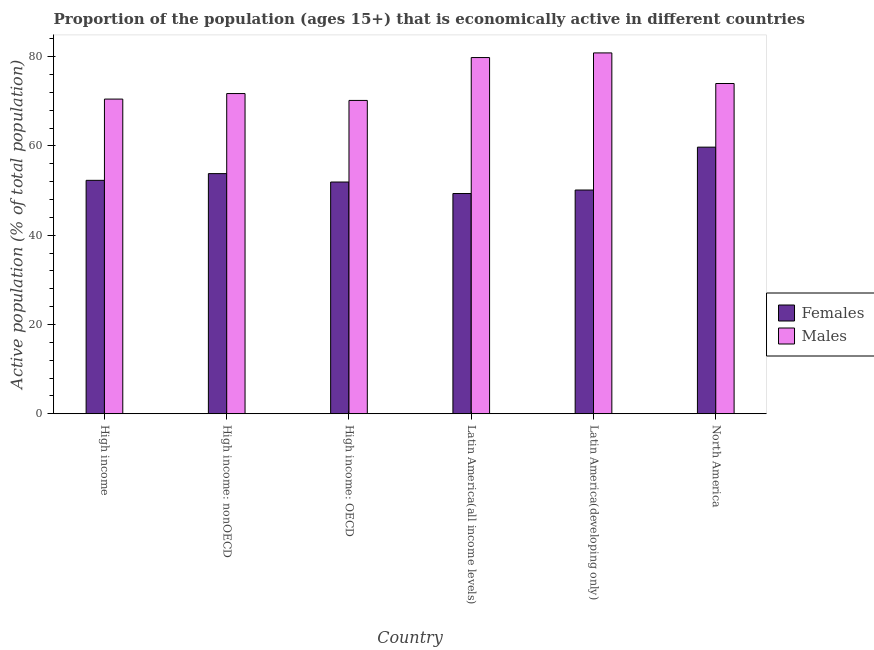How many different coloured bars are there?
Give a very brief answer. 2. How many groups of bars are there?
Give a very brief answer. 6. Are the number of bars on each tick of the X-axis equal?
Your answer should be compact. Yes. How many bars are there on the 3rd tick from the left?
Your answer should be compact. 2. What is the label of the 5th group of bars from the left?
Your answer should be compact. Latin America(developing only). What is the percentage of economically active male population in Latin America(developing only)?
Provide a short and direct response. 80.84. Across all countries, what is the maximum percentage of economically active male population?
Give a very brief answer. 80.84. Across all countries, what is the minimum percentage of economically active male population?
Ensure brevity in your answer.  70.19. In which country was the percentage of economically active male population maximum?
Provide a succinct answer. Latin America(developing only). In which country was the percentage of economically active female population minimum?
Your answer should be very brief. Latin America(all income levels). What is the total percentage of economically active male population in the graph?
Offer a terse response. 447.06. What is the difference between the percentage of economically active male population in High income: nonOECD and that in Latin America(all income levels)?
Your answer should be very brief. -8.06. What is the difference between the percentage of economically active female population in Latin America(developing only) and the percentage of economically active male population in High income?
Provide a succinct answer. -20.37. What is the average percentage of economically active male population per country?
Ensure brevity in your answer.  74.51. What is the difference between the percentage of economically active female population and percentage of economically active male population in Latin America(all income levels)?
Make the answer very short. -30.46. What is the ratio of the percentage of economically active female population in High income: OECD to that in Latin America(all income levels)?
Make the answer very short. 1.05. What is the difference between the highest and the second highest percentage of economically active male population?
Your response must be concise. 1.04. What is the difference between the highest and the lowest percentage of economically active male population?
Provide a short and direct response. 10.65. In how many countries, is the percentage of economically active male population greater than the average percentage of economically active male population taken over all countries?
Offer a terse response. 2. Is the sum of the percentage of economically active female population in High income and High income: nonOECD greater than the maximum percentage of economically active male population across all countries?
Provide a short and direct response. Yes. What does the 2nd bar from the left in High income: OECD represents?
Provide a short and direct response. Males. What does the 2nd bar from the right in Latin America(developing only) represents?
Offer a very short reply. Females. How many bars are there?
Give a very brief answer. 12. Are all the bars in the graph horizontal?
Provide a short and direct response. No. How many countries are there in the graph?
Make the answer very short. 6. Does the graph contain grids?
Offer a terse response. No. What is the title of the graph?
Provide a short and direct response. Proportion of the population (ages 15+) that is economically active in different countries. Does "Overweight" appear as one of the legend labels in the graph?
Offer a terse response. No. What is the label or title of the X-axis?
Offer a very short reply. Country. What is the label or title of the Y-axis?
Provide a succinct answer. Active population (% of total population). What is the Active population (% of total population) in Females in High income?
Provide a succinct answer. 52.29. What is the Active population (% of total population) of Males in High income?
Provide a succinct answer. 70.5. What is the Active population (% of total population) in Females in High income: nonOECD?
Your answer should be compact. 53.8. What is the Active population (% of total population) of Males in High income: nonOECD?
Your answer should be very brief. 71.74. What is the Active population (% of total population) in Females in High income: OECD?
Ensure brevity in your answer.  51.91. What is the Active population (% of total population) in Males in High income: OECD?
Make the answer very short. 70.19. What is the Active population (% of total population) of Females in Latin America(all income levels)?
Provide a short and direct response. 49.34. What is the Active population (% of total population) in Males in Latin America(all income levels)?
Give a very brief answer. 79.8. What is the Active population (% of total population) in Females in Latin America(developing only)?
Your response must be concise. 50.12. What is the Active population (% of total population) in Males in Latin America(developing only)?
Keep it short and to the point. 80.84. What is the Active population (% of total population) of Females in North America?
Your answer should be very brief. 59.73. What is the Active population (% of total population) in Males in North America?
Offer a very short reply. 73.99. Across all countries, what is the maximum Active population (% of total population) of Females?
Give a very brief answer. 59.73. Across all countries, what is the maximum Active population (% of total population) in Males?
Offer a terse response. 80.84. Across all countries, what is the minimum Active population (% of total population) in Females?
Make the answer very short. 49.34. Across all countries, what is the minimum Active population (% of total population) in Males?
Provide a short and direct response. 70.19. What is the total Active population (% of total population) of Females in the graph?
Provide a succinct answer. 317.2. What is the total Active population (% of total population) of Males in the graph?
Provide a short and direct response. 447.06. What is the difference between the Active population (% of total population) in Females in High income and that in High income: nonOECD?
Your response must be concise. -1.5. What is the difference between the Active population (% of total population) in Males in High income and that in High income: nonOECD?
Ensure brevity in your answer.  -1.24. What is the difference between the Active population (% of total population) of Females in High income and that in High income: OECD?
Offer a very short reply. 0.38. What is the difference between the Active population (% of total population) of Males in High income and that in High income: OECD?
Your answer should be very brief. 0.3. What is the difference between the Active population (% of total population) in Females in High income and that in Latin America(all income levels)?
Provide a short and direct response. 2.96. What is the difference between the Active population (% of total population) in Males in High income and that in Latin America(all income levels)?
Your response must be concise. -9.31. What is the difference between the Active population (% of total population) in Females in High income and that in Latin America(developing only)?
Keep it short and to the point. 2.17. What is the difference between the Active population (% of total population) of Males in High income and that in Latin America(developing only)?
Make the answer very short. -10.35. What is the difference between the Active population (% of total population) of Females in High income and that in North America?
Keep it short and to the point. -7.44. What is the difference between the Active population (% of total population) in Males in High income and that in North America?
Give a very brief answer. -3.49. What is the difference between the Active population (% of total population) of Females in High income: nonOECD and that in High income: OECD?
Offer a very short reply. 1.88. What is the difference between the Active population (% of total population) in Males in High income: nonOECD and that in High income: OECD?
Give a very brief answer. 1.54. What is the difference between the Active population (% of total population) in Females in High income: nonOECD and that in Latin America(all income levels)?
Provide a short and direct response. 4.46. What is the difference between the Active population (% of total population) in Males in High income: nonOECD and that in Latin America(all income levels)?
Ensure brevity in your answer.  -8.06. What is the difference between the Active population (% of total population) in Females in High income: nonOECD and that in Latin America(developing only)?
Ensure brevity in your answer.  3.68. What is the difference between the Active population (% of total population) of Males in High income: nonOECD and that in Latin America(developing only)?
Your answer should be very brief. -9.1. What is the difference between the Active population (% of total population) of Females in High income: nonOECD and that in North America?
Ensure brevity in your answer.  -5.93. What is the difference between the Active population (% of total population) of Males in High income: nonOECD and that in North America?
Offer a terse response. -2.25. What is the difference between the Active population (% of total population) of Females in High income: OECD and that in Latin America(all income levels)?
Your answer should be compact. 2.58. What is the difference between the Active population (% of total population) of Males in High income: OECD and that in Latin America(all income levels)?
Your response must be concise. -9.61. What is the difference between the Active population (% of total population) of Females in High income: OECD and that in Latin America(developing only)?
Your response must be concise. 1.79. What is the difference between the Active population (% of total population) of Males in High income: OECD and that in Latin America(developing only)?
Your response must be concise. -10.65. What is the difference between the Active population (% of total population) of Females in High income: OECD and that in North America?
Give a very brief answer. -7.82. What is the difference between the Active population (% of total population) in Males in High income: OECD and that in North America?
Your answer should be very brief. -3.79. What is the difference between the Active population (% of total population) of Females in Latin America(all income levels) and that in Latin America(developing only)?
Provide a succinct answer. -0.78. What is the difference between the Active population (% of total population) of Males in Latin America(all income levels) and that in Latin America(developing only)?
Your answer should be very brief. -1.04. What is the difference between the Active population (% of total population) of Females in Latin America(all income levels) and that in North America?
Offer a very short reply. -10.39. What is the difference between the Active population (% of total population) of Males in Latin America(all income levels) and that in North America?
Make the answer very short. 5.81. What is the difference between the Active population (% of total population) of Females in Latin America(developing only) and that in North America?
Ensure brevity in your answer.  -9.61. What is the difference between the Active population (% of total population) of Males in Latin America(developing only) and that in North America?
Make the answer very short. 6.85. What is the difference between the Active population (% of total population) of Females in High income and the Active population (% of total population) of Males in High income: nonOECD?
Offer a terse response. -19.44. What is the difference between the Active population (% of total population) of Females in High income and the Active population (% of total population) of Males in High income: OECD?
Ensure brevity in your answer.  -17.9. What is the difference between the Active population (% of total population) of Females in High income and the Active population (% of total population) of Males in Latin America(all income levels)?
Keep it short and to the point. -27.51. What is the difference between the Active population (% of total population) of Females in High income and the Active population (% of total population) of Males in Latin America(developing only)?
Offer a terse response. -28.55. What is the difference between the Active population (% of total population) in Females in High income and the Active population (% of total population) in Males in North America?
Make the answer very short. -21.69. What is the difference between the Active population (% of total population) of Females in High income: nonOECD and the Active population (% of total population) of Males in High income: OECD?
Offer a very short reply. -16.4. What is the difference between the Active population (% of total population) of Females in High income: nonOECD and the Active population (% of total population) of Males in Latin America(all income levels)?
Keep it short and to the point. -26. What is the difference between the Active population (% of total population) in Females in High income: nonOECD and the Active population (% of total population) in Males in Latin America(developing only)?
Offer a terse response. -27.04. What is the difference between the Active population (% of total population) of Females in High income: nonOECD and the Active population (% of total population) of Males in North America?
Offer a terse response. -20.19. What is the difference between the Active population (% of total population) of Females in High income: OECD and the Active population (% of total population) of Males in Latin America(all income levels)?
Your answer should be very brief. -27.89. What is the difference between the Active population (% of total population) in Females in High income: OECD and the Active population (% of total population) in Males in Latin America(developing only)?
Offer a terse response. -28.93. What is the difference between the Active population (% of total population) in Females in High income: OECD and the Active population (% of total population) in Males in North America?
Your answer should be very brief. -22.07. What is the difference between the Active population (% of total population) of Females in Latin America(all income levels) and the Active population (% of total population) of Males in Latin America(developing only)?
Ensure brevity in your answer.  -31.5. What is the difference between the Active population (% of total population) of Females in Latin America(all income levels) and the Active population (% of total population) of Males in North America?
Your answer should be very brief. -24.65. What is the difference between the Active population (% of total population) of Females in Latin America(developing only) and the Active population (% of total population) of Males in North America?
Make the answer very short. -23.87. What is the average Active population (% of total population) in Females per country?
Your response must be concise. 52.87. What is the average Active population (% of total population) of Males per country?
Your response must be concise. 74.51. What is the difference between the Active population (% of total population) of Females and Active population (% of total population) of Males in High income?
Provide a short and direct response. -18.2. What is the difference between the Active population (% of total population) in Females and Active population (% of total population) in Males in High income: nonOECD?
Your response must be concise. -17.94. What is the difference between the Active population (% of total population) of Females and Active population (% of total population) of Males in High income: OECD?
Offer a terse response. -18.28. What is the difference between the Active population (% of total population) in Females and Active population (% of total population) in Males in Latin America(all income levels)?
Offer a very short reply. -30.46. What is the difference between the Active population (% of total population) of Females and Active population (% of total population) of Males in Latin America(developing only)?
Your answer should be very brief. -30.72. What is the difference between the Active population (% of total population) in Females and Active population (% of total population) in Males in North America?
Offer a terse response. -14.26. What is the ratio of the Active population (% of total population) in Females in High income to that in High income: nonOECD?
Offer a very short reply. 0.97. What is the ratio of the Active population (% of total population) in Males in High income to that in High income: nonOECD?
Provide a short and direct response. 0.98. What is the ratio of the Active population (% of total population) of Females in High income to that in High income: OECD?
Give a very brief answer. 1.01. What is the ratio of the Active population (% of total population) of Females in High income to that in Latin America(all income levels)?
Your answer should be compact. 1.06. What is the ratio of the Active population (% of total population) of Males in High income to that in Latin America(all income levels)?
Give a very brief answer. 0.88. What is the ratio of the Active population (% of total population) of Females in High income to that in Latin America(developing only)?
Provide a short and direct response. 1.04. What is the ratio of the Active population (% of total population) of Males in High income to that in Latin America(developing only)?
Offer a terse response. 0.87. What is the ratio of the Active population (% of total population) of Females in High income to that in North America?
Ensure brevity in your answer.  0.88. What is the ratio of the Active population (% of total population) of Males in High income to that in North America?
Your answer should be compact. 0.95. What is the ratio of the Active population (% of total population) of Females in High income: nonOECD to that in High income: OECD?
Offer a terse response. 1.04. What is the ratio of the Active population (% of total population) in Females in High income: nonOECD to that in Latin America(all income levels)?
Your answer should be very brief. 1.09. What is the ratio of the Active population (% of total population) in Males in High income: nonOECD to that in Latin America(all income levels)?
Provide a succinct answer. 0.9. What is the ratio of the Active population (% of total population) in Females in High income: nonOECD to that in Latin America(developing only)?
Keep it short and to the point. 1.07. What is the ratio of the Active population (% of total population) in Males in High income: nonOECD to that in Latin America(developing only)?
Give a very brief answer. 0.89. What is the ratio of the Active population (% of total population) in Females in High income: nonOECD to that in North America?
Keep it short and to the point. 0.9. What is the ratio of the Active population (% of total population) of Males in High income: nonOECD to that in North America?
Give a very brief answer. 0.97. What is the ratio of the Active population (% of total population) in Females in High income: OECD to that in Latin America(all income levels)?
Your response must be concise. 1.05. What is the ratio of the Active population (% of total population) in Males in High income: OECD to that in Latin America(all income levels)?
Your response must be concise. 0.88. What is the ratio of the Active population (% of total population) in Females in High income: OECD to that in Latin America(developing only)?
Offer a terse response. 1.04. What is the ratio of the Active population (% of total population) in Males in High income: OECD to that in Latin America(developing only)?
Give a very brief answer. 0.87. What is the ratio of the Active population (% of total population) in Females in High income: OECD to that in North America?
Make the answer very short. 0.87. What is the ratio of the Active population (% of total population) in Males in High income: OECD to that in North America?
Keep it short and to the point. 0.95. What is the ratio of the Active population (% of total population) of Females in Latin America(all income levels) to that in Latin America(developing only)?
Make the answer very short. 0.98. What is the ratio of the Active population (% of total population) in Males in Latin America(all income levels) to that in Latin America(developing only)?
Keep it short and to the point. 0.99. What is the ratio of the Active population (% of total population) of Females in Latin America(all income levels) to that in North America?
Give a very brief answer. 0.83. What is the ratio of the Active population (% of total population) of Males in Latin America(all income levels) to that in North America?
Give a very brief answer. 1.08. What is the ratio of the Active population (% of total population) in Females in Latin America(developing only) to that in North America?
Give a very brief answer. 0.84. What is the ratio of the Active population (% of total population) of Males in Latin America(developing only) to that in North America?
Give a very brief answer. 1.09. What is the difference between the highest and the second highest Active population (% of total population) of Females?
Keep it short and to the point. 5.93. What is the difference between the highest and the second highest Active population (% of total population) of Males?
Ensure brevity in your answer.  1.04. What is the difference between the highest and the lowest Active population (% of total population) in Females?
Provide a short and direct response. 10.39. What is the difference between the highest and the lowest Active population (% of total population) in Males?
Offer a very short reply. 10.65. 